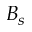Convert formula to latex. <formula><loc_0><loc_0><loc_500><loc_500>B _ { s }</formula> 